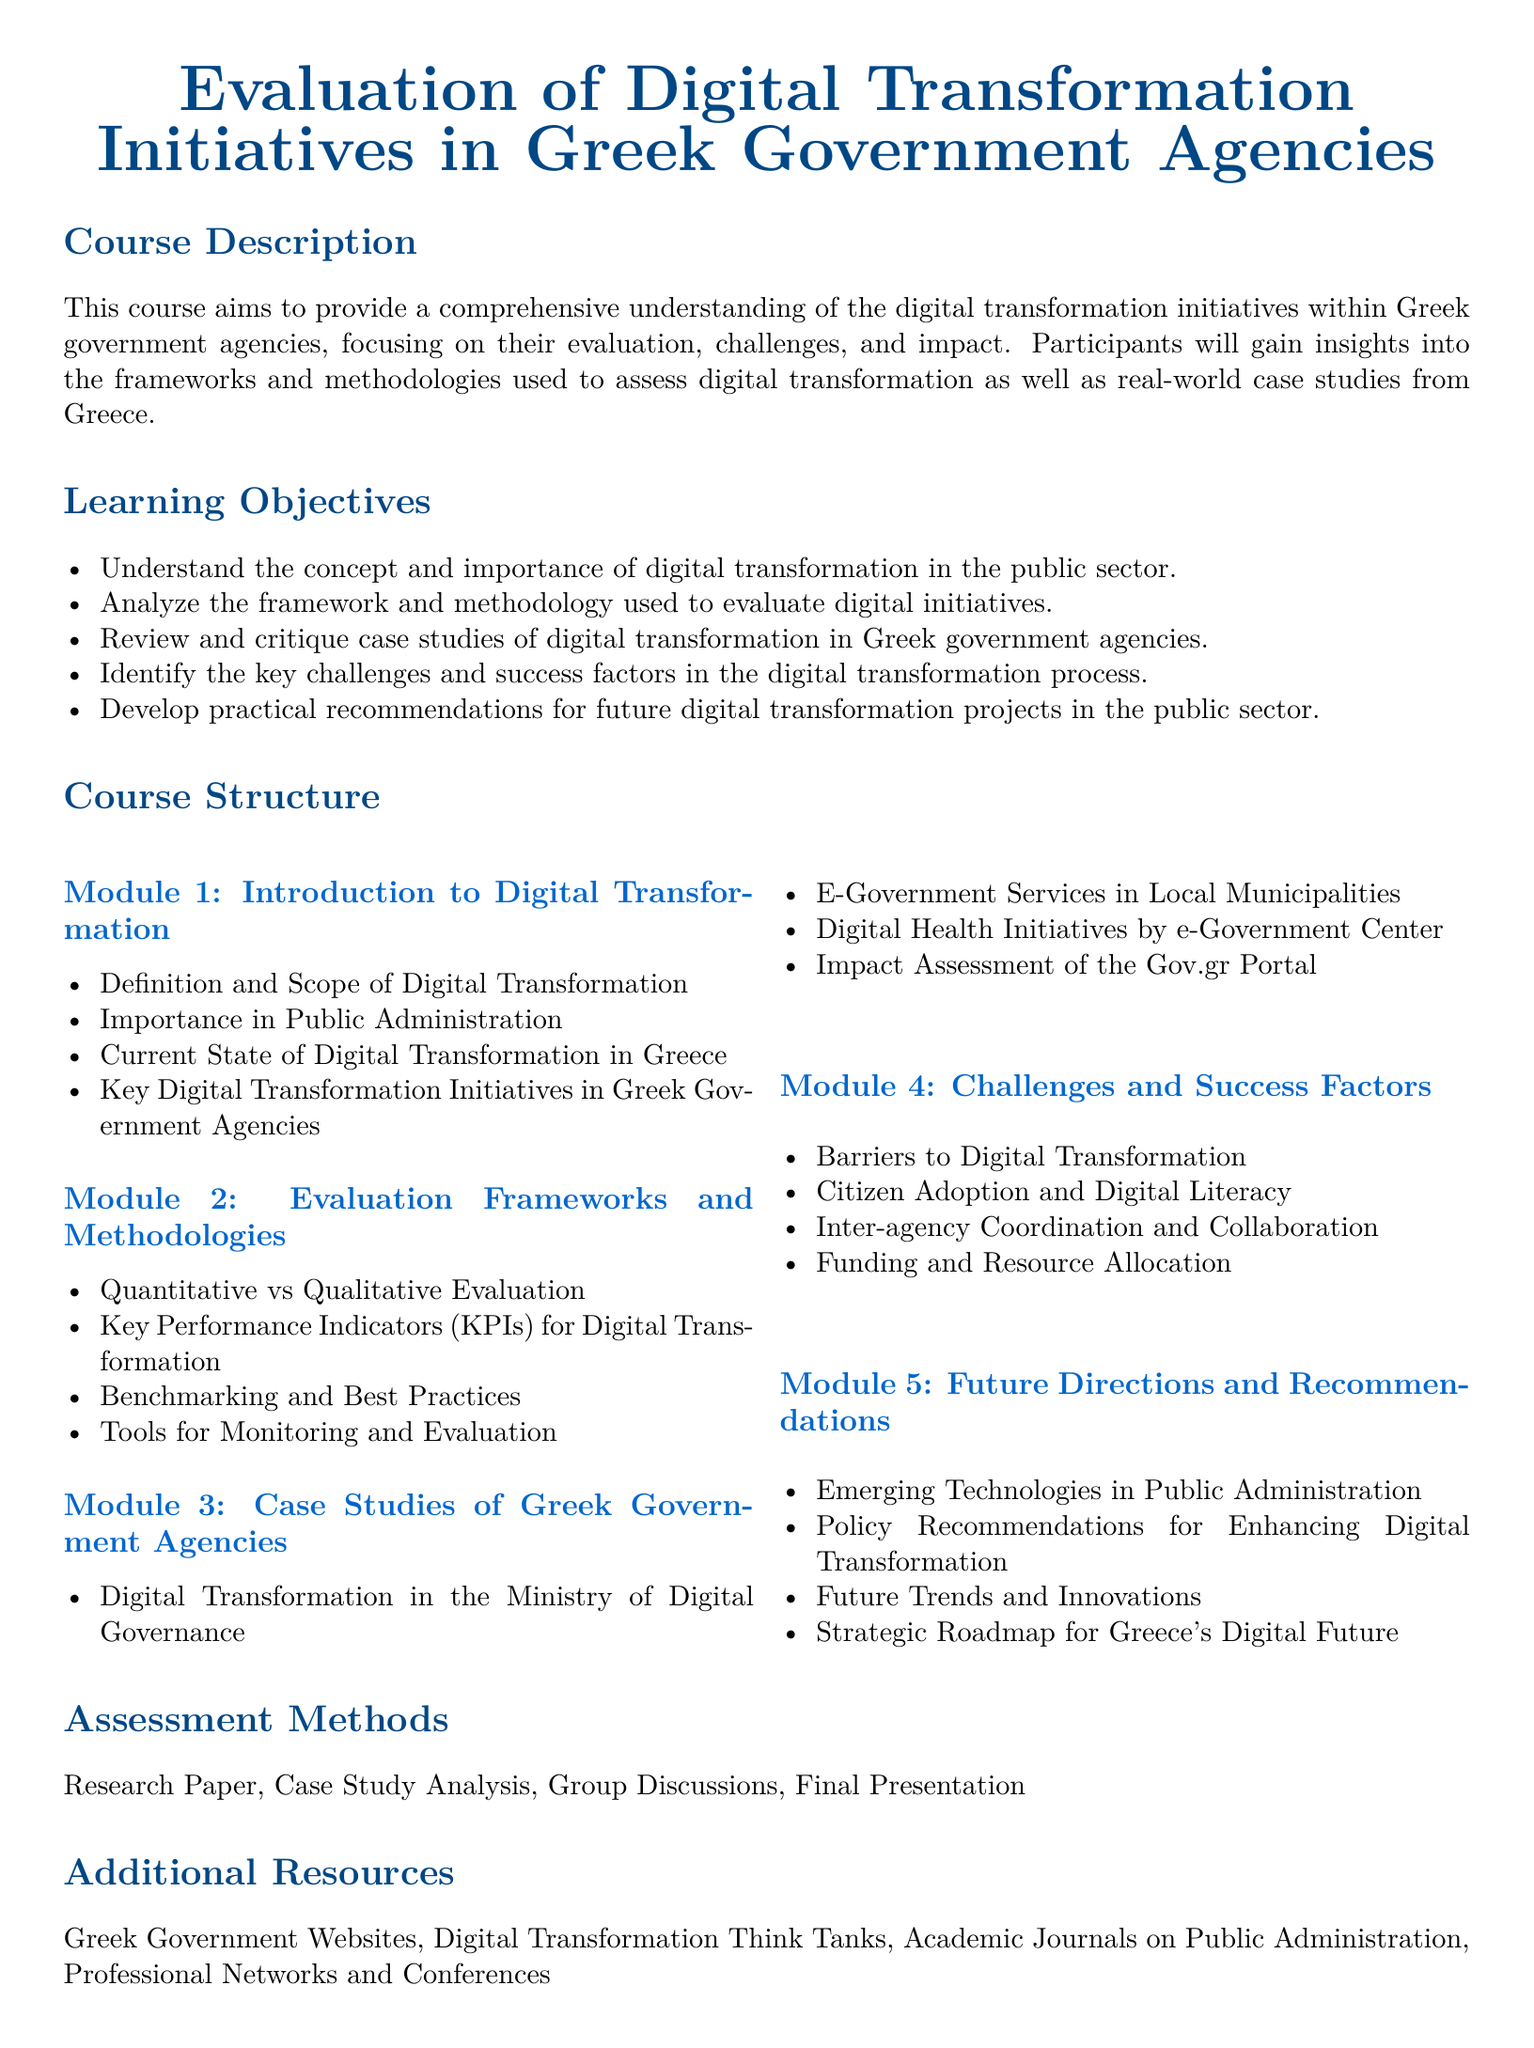What is the title of the syllabus? The title of the syllabus is clearly indicated at the beginning of the document.
Answer: Evaluation of Digital Transformation Initiatives in Greek Government Agencies What is the main focus of this course? The course description highlights the central theme of the course.
Answer: Evaluation of digital transformation initiatives What are the two types of evaluation mentioned in the document? The syllabus specifies the types of evaluation frameworks to be discussed.
Answer: Quantitative and Qualitative Which agency's digital transformation is highlighted in Module 3? The case studies section mentions a specific government agency's initiatives.
Answer: Ministry of Digital Governance What are the barriers to digital transformation discussed in Module 4? This section outlines various challenges faced during the digital transformation process.
Answer: Barriers to Digital Transformation What type of assessment methods are included in the syllabus? The assessment section details the methods used to evaluate participants' understanding.
Answer: Research Paper, Case Study Analysis, Group Discussions, Final Presentation What is one resource type mentioned for additional reading? The additional resources section lists types of resources participants can refer to.
Answer: Academic Journals on Public Administration How many modules are outlined in the course structure? The course structure section indicates the total number of modules included.
Answer: Five 